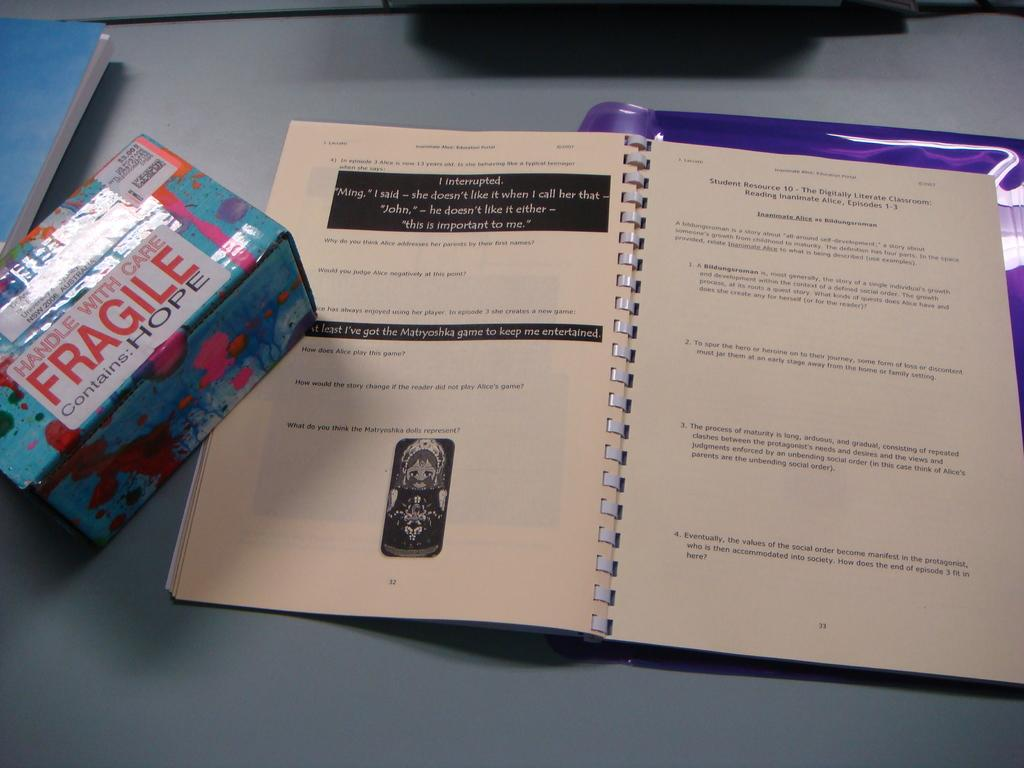Provide a one-sentence caption for the provided image. Booklet next to a box that says fragile on the front. 